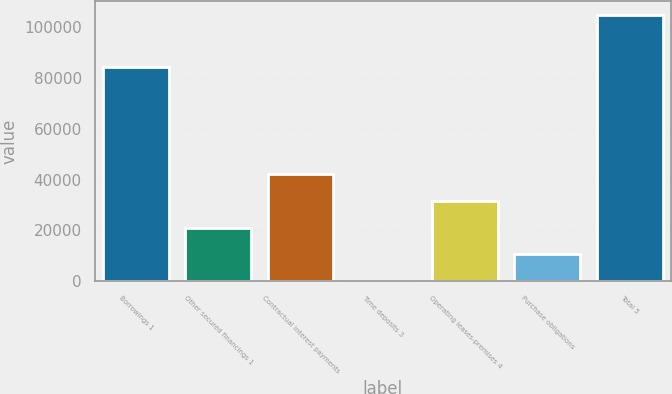Convert chart. <chart><loc_0><loc_0><loc_500><loc_500><bar_chart><fcel>Borrowings 1<fcel>Other secured financings 1<fcel>Contractual interest payments<fcel>Time deposits 3<fcel>Operating leases-premises 4<fcel>Purchase obligations<fcel>Total 5<nl><fcel>84581<fcel>21098.2<fcel>42067.4<fcel>129<fcel>31582.8<fcel>10613.6<fcel>104975<nl></chart> 